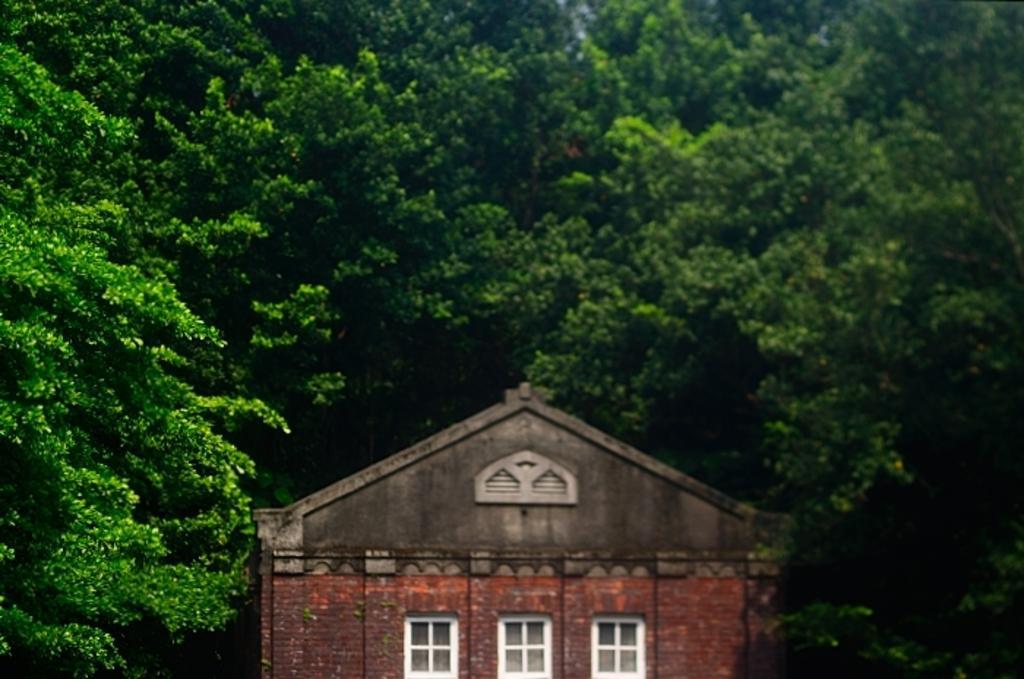Could you give a brief overview of what you see in this image? In this image there is a house having windows. Background there are trees. 